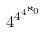<formula> <loc_0><loc_0><loc_500><loc_500>4 ^ { 4 ^ { 4 ^ { \aleph _ { 0 } } } }</formula> 